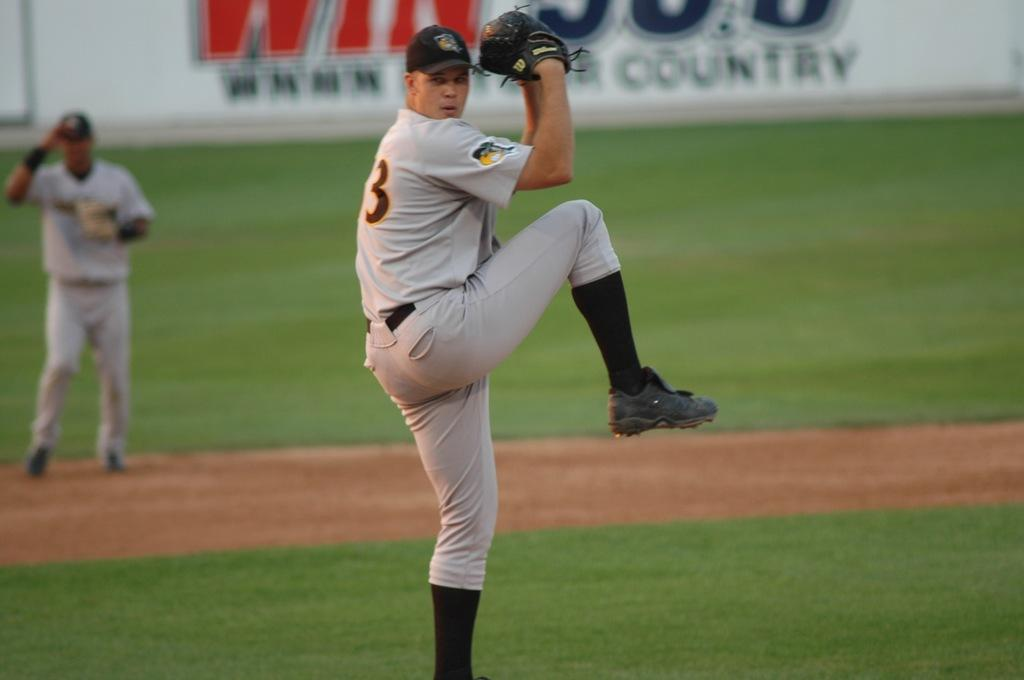<image>
Relay a brief, clear account of the picture shown. Player 3 winds up to pitch in front of an ad for a country station. 